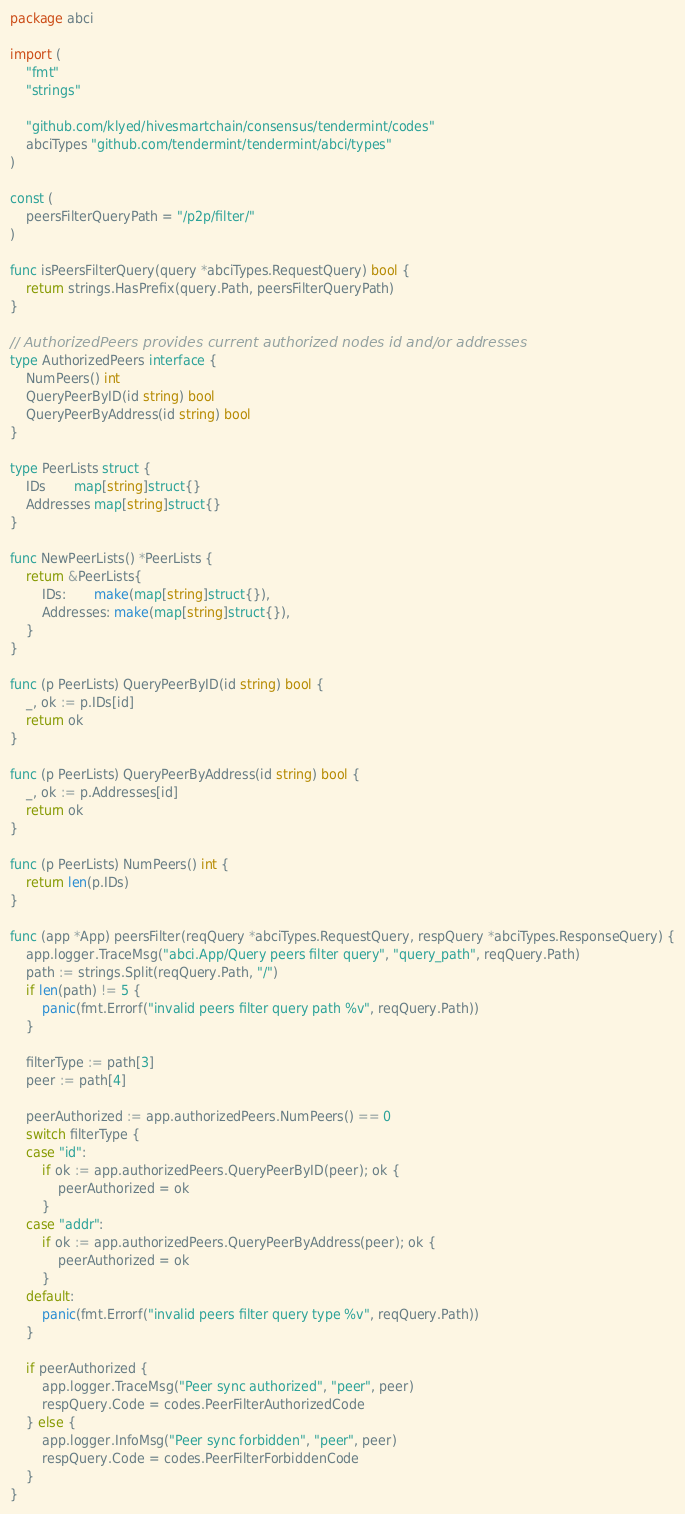<code> <loc_0><loc_0><loc_500><loc_500><_Go_>package abci

import (
	"fmt"
	"strings"

	"github.com/klyed/hivesmartchain/consensus/tendermint/codes"
	abciTypes "github.com/tendermint/tendermint/abci/types"
)

const (
	peersFilterQueryPath = "/p2p/filter/"
)

func isPeersFilterQuery(query *abciTypes.RequestQuery) bool {
	return strings.HasPrefix(query.Path, peersFilterQueryPath)
}

// AuthorizedPeers provides current authorized nodes id and/or addresses
type AuthorizedPeers interface {
	NumPeers() int
	QueryPeerByID(id string) bool
	QueryPeerByAddress(id string) bool
}

type PeerLists struct {
	IDs       map[string]struct{}
	Addresses map[string]struct{}
}

func NewPeerLists() *PeerLists {
	return &PeerLists{
		IDs:       make(map[string]struct{}),
		Addresses: make(map[string]struct{}),
	}
}

func (p PeerLists) QueryPeerByID(id string) bool {
	_, ok := p.IDs[id]
	return ok
}

func (p PeerLists) QueryPeerByAddress(id string) bool {
	_, ok := p.Addresses[id]
	return ok
}

func (p PeerLists) NumPeers() int {
	return len(p.IDs)
}

func (app *App) peersFilter(reqQuery *abciTypes.RequestQuery, respQuery *abciTypes.ResponseQuery) {
	app.logger.TraceMsg("abci.App/Query peers filter query", "query_path", reqQuery.Path)
	path := strings.Split(reqQuery.Path, "/")
	if len(path) != 5 {
		panic(fmt.Errorf("invalid peers filter query path %v", reqQuery.Path))
	}

	filterType := path[3]
	peer := path[4]

	peerAuthorized := app.authorizedPeers.NumPeers() == 0
	switch filterType {
	case "id":
		if ok := app.authorizedPeers.QueryPeerByID(peer); ok {
			peerAuthorized = ok
		}
	case "addr":
		if ok := app.authorizedPeers.QueryPeerByAddress(peer); ok {
			peerAuthorized = ok
		}
	default:
		panic(fmt.Errorf("invalid peers filter query type %v", reqQuery.Path))
	}

	if peerAuthorized {
		app.logger.TraceMsg("Peer sync authorized", "peer", peer)
		respQuery.Code = codes.PeerFilterAuthorizedCode
	} else {
		app.logger.InfoMsg("Peer sync forbidden", "peer", peer)
		respQuery.Code = codes.PeerFilterForbiddenCode
	}
}
</code> 